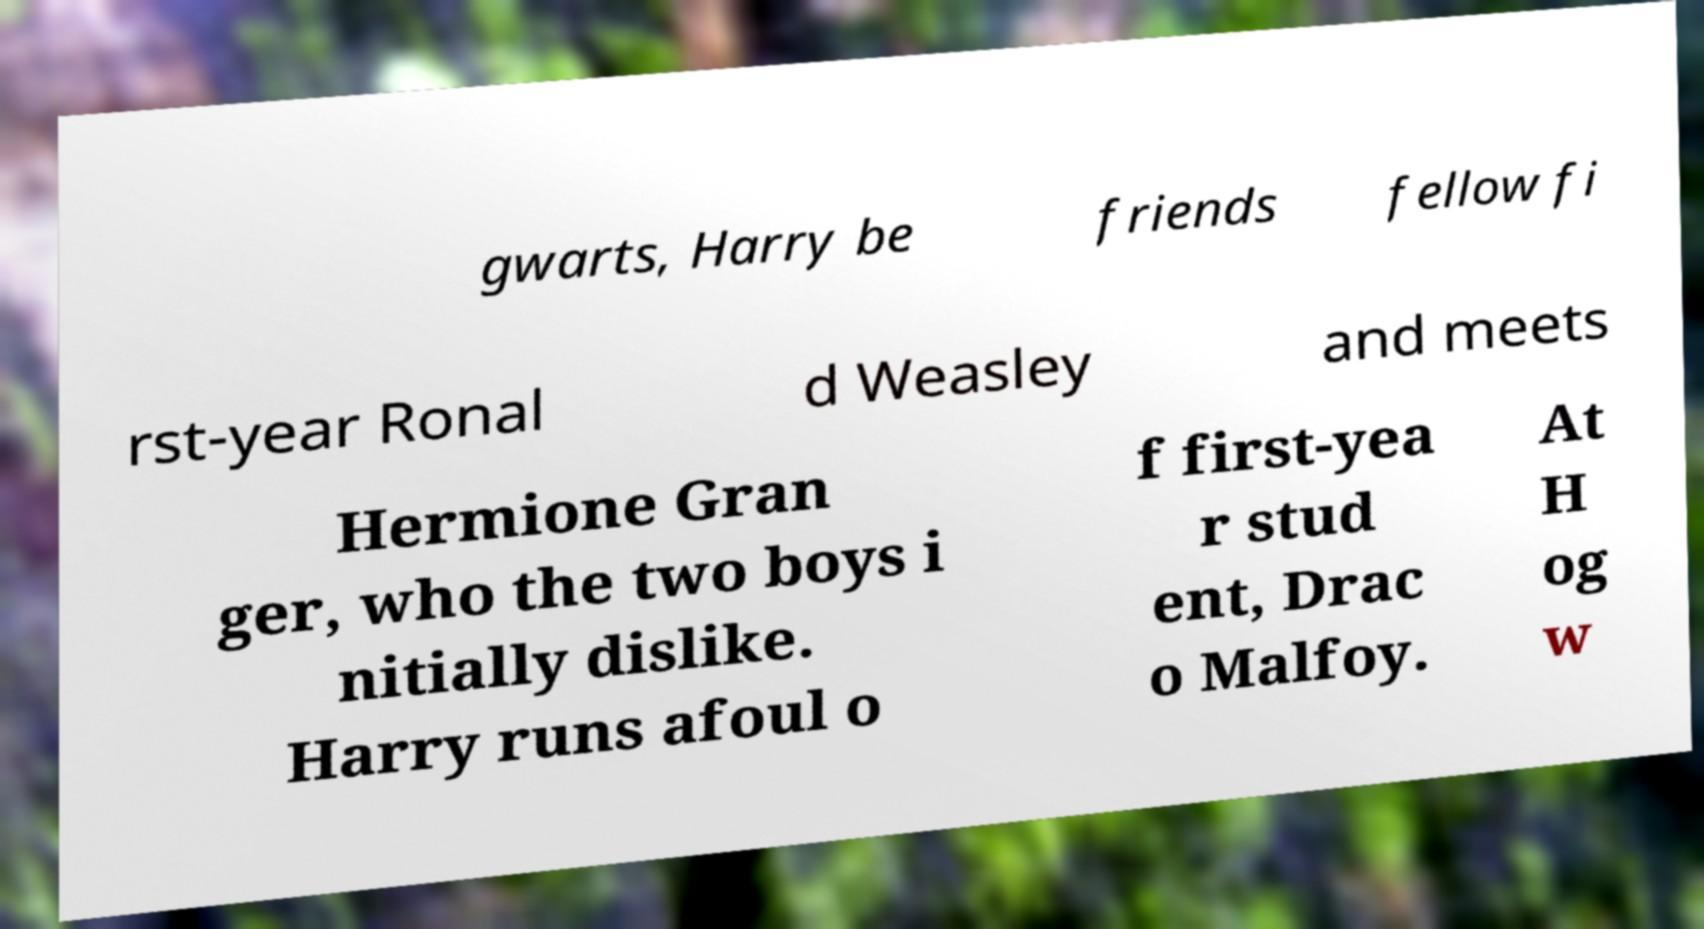Could you assist in decoding the text presented in this image and type it out clearly? gwarts, Harry be friends fellow fi rst-year Ronal d Weasley and meets Hermione Gran ger, who the two boys i nitially dislike. Harry runs afoul o f first-yea r stud ent, Drac o Malfoy. At H og w 